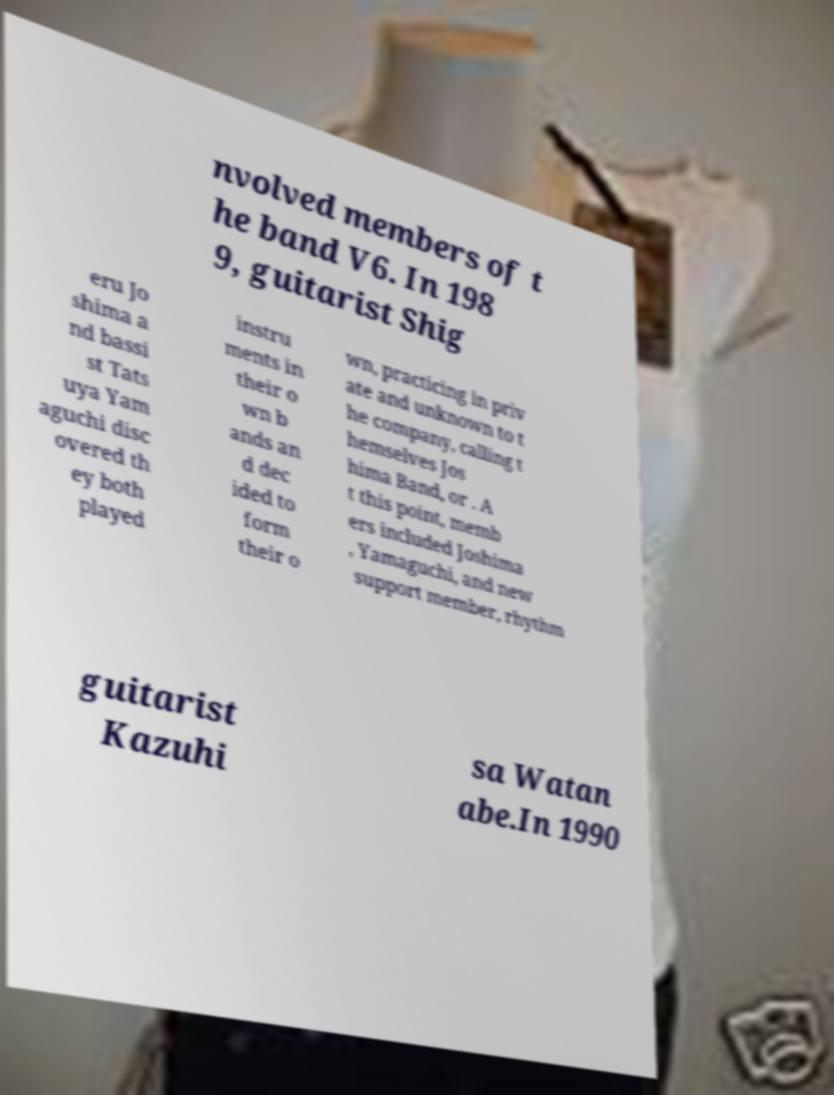Can you read and provide the text displayed in the image?This photo seems to have some interesting text. Can you extract and type it out for me? nvolved members of t he band V6. In 198 9, guitarist Shig eru Jo shima a nd bassi st Tats uya Yam aguchi disc overed th ey both played instru ments in their o wn b ands an d dec ided to form their o wn, practicing in priv ate and unknown to t he company, calling t hemselves Jos hima Band, or . A t this point, memb ers included Joshima , Yamaguchi, and new support member, rhythm guitarist Kazuhi sa Watan abe.In 1990 